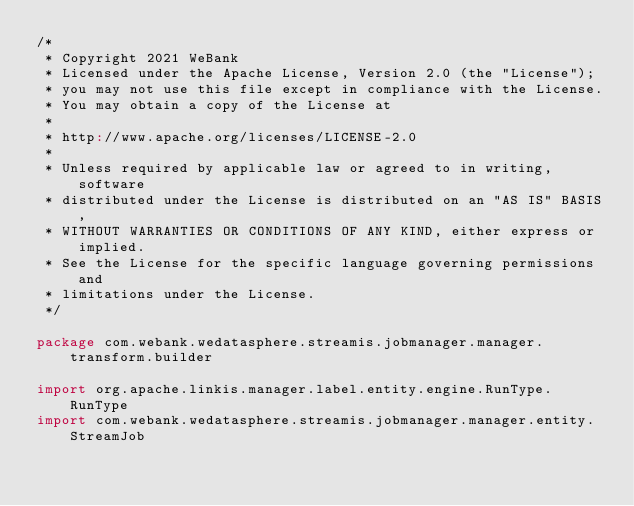Convert code to text. <code><loc_0><loc_0><loc_500><loc_500><_Scala_>/*
 * Copyright 2021 WeBank
 * Licensed under the Apache License, Version 2.0 (the "License");
 * you may not use this file except in compliance with the License.
 * You may obtain a copy of the License at
 *
 * http://www.apache.org/licenses/LICENSE-2.0
 *
 * Unless required by applicable law or agreed to in writing, software
 * distributed under the License is distributed on an "AS IS" BASIS,
 * WITHOUT WARRANTIES OR CONDITIONS OF ANY KIND, either express or implied.
 * See the License for the specific language governing permissions and
 * limitations under the License.
 */

package com.webank.wedatasphere.streamis.jobmanager.manager.transform.builder

import org.apache.linkis.manager.label.entity.engine.RunType.RunType
import com.webank.wedatasphere.streamis.jobmanager.manager.entity.StreamJob</code> 